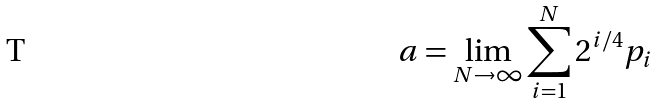Convert formula to latex. <formula><loc_0><loc_0><loc_500><loc_500>a = \lim _ { N \to \infty } \sum _ { i = 1 } ^ { N } 2 ^ { i / 4 } p _ { i }</formula> 